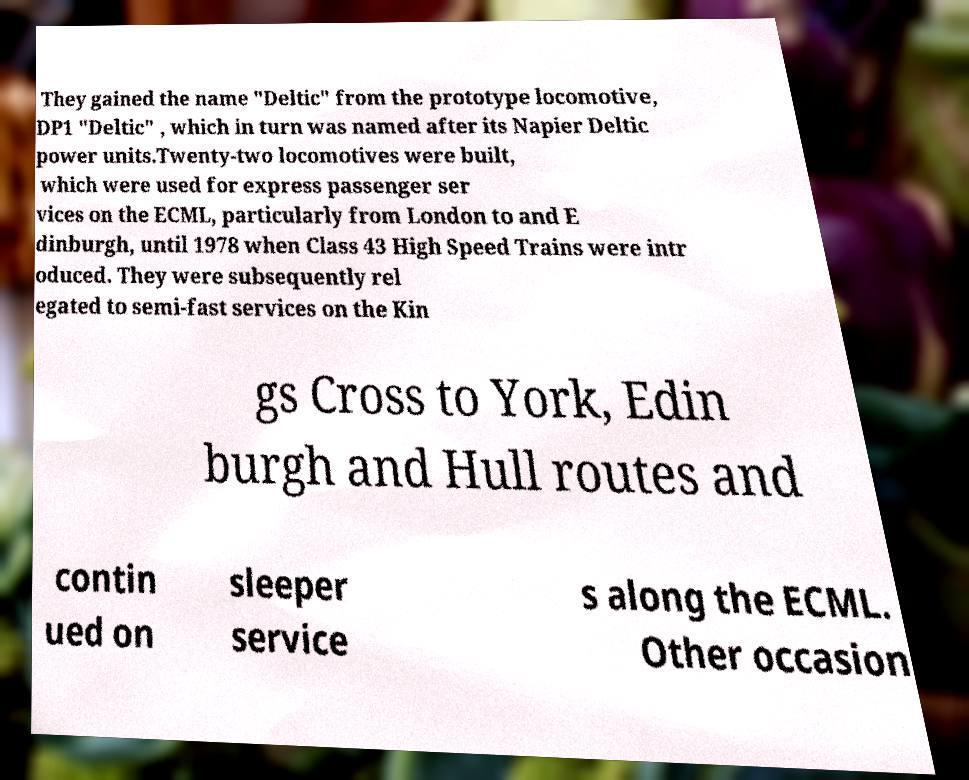For documentation purposes, I need the text within this image transcribed. Could you provide that? They gained the name "Deltic" from the prototype locomotive, DP1 "Deltic" , which in turn was named after its Napier Deltic power units.Twenty-two locomotives were built, which were used for express passenger ser vices on the ECML, particularly from London to and E dinburgh, until 1978 when Class 43 High Speed Trains were intr oduced. They were subsequently rel egated to semi-fast services on the Kin gs Cross to York, Edin burgh and Hull routes and contin ued on sleeper service s along the ECML. Other occasion 